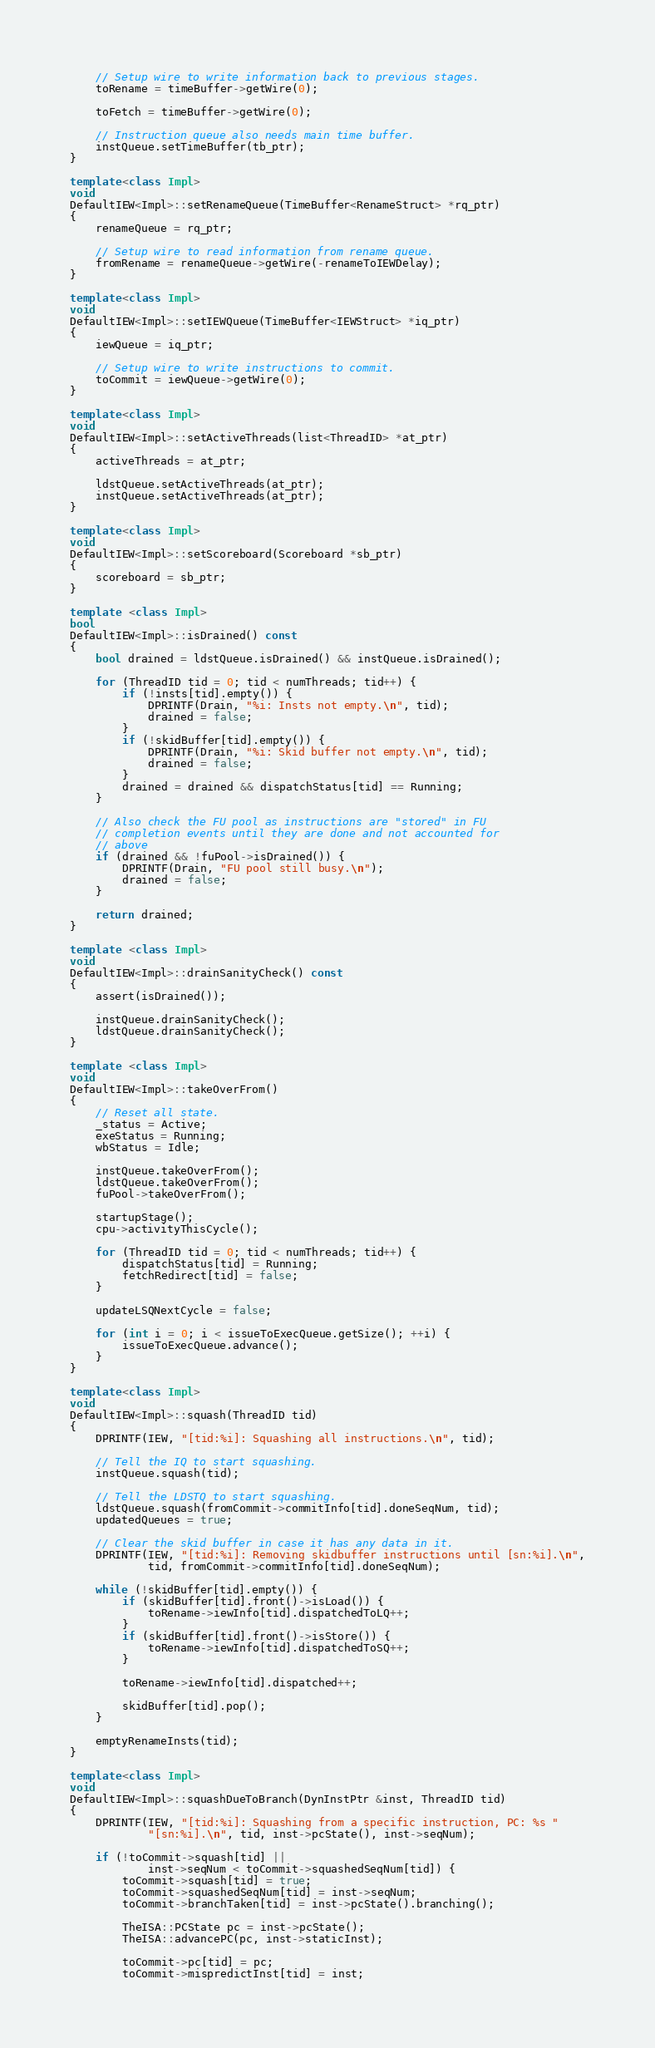Convert code to text. <code><loc_0><loc_0><loc_500><loc_500><_C++_>    // Setup wire to write information back to previous stages.
    toRename = timeBuffer->getWire(0);

    toFetch = timeBuffer->getWire(0);

    // Instruction queue also needs main time buffer.
    instQueue.setTimeBuffer(tb_ptr);
}

template<class Impl>
void
DefaultIEW<Impl>::setRenameQueue(TimeBuffer<RenameStruct> *rq_ptr)
{
    renameQueue = rq_ptr;

    // Setup wire to read information from rename queue.
    fromRename = renameQueue->getWire(-renameToIEWDelay);
}

template<class Impl>
void
DefaultIEW<Impl>::setIEWQueue(TimeBuffer<IEWStruct> *iq_ptr)
{
    iewQueue = iq_ptr;

    // Setup wire to write instructions to commit.
    toCommit = iewQueue->getWire(0);
}

template<class Impl>
void
DefaultIEW<Impl>::setActiveThreads(list<ThreadID> *at_ptr)
{
    activeThreads = at_ptr;

    ldstQueue.setActiveThreads(at_ptr);
    instQueue.setActiveThreads(at_ptr);
}

template<class Impl>
void
DefaultIEW<Impl>::setScoreboard(Scoreboard *sb_ptr)
{
    scoreboard = sb_ptr;
}

template <class Impl>
bool
DefaultIEW<Impl>::isDrained() const
{
    bool drained = ldstQueue.isDrained() && instQueue.isDrained();

    for (ThreadID tid = 0; tid < numThreads; tid++) {
        if (!insts[tid].empty()) {
            DPRINTF(Drain, "%i: Insts not empty.\n", tid);
            drained = false;
        }
        if (!skidBuffer[tid].empty()) {
            DPRINTF(Drain, "%i: Skid buffer not empty.\n", tid);
            drained = false;
        }
        drained = drained && dispatchStatus[tid] == Running;
    }

    // Also check the FU pool as instructions are "stored" in FU
    // completion events until they are done and not accounted for
    // above
    if (drained && !fuPool->isDrained()) {
        DPRINTF(Drain, "FU pool still busy.\n");
        drained = false;
    }

    return drained;
}

template <class Impl>
void
DefaultIEW<Impl>::drainSanityCheck() const
{
    assert(isDrained());

    instQueue.drainSanityCheck();
    ldstQueue.drainSanityCheck();
}

template <class Impl>
void
DefaultIEW<Impl>::takeOverFrom()
{
    // Reset all state.
    _status = Active;
    exeStatus = Running;
    wbStatus = Idle;

    instQueue.takeOverFrom();
    ldstQueue.takeOverFrom();
    fuPool->takeOverFrom();

    startupStage();
    cpu->activityThisCycle();

    for (ThreadID tid = 0; tid < numThreads; tid++) {
        dispatchStatus[tid] = Running;
        fetchRedirect[tid] = false;
    }

    updateLSQNextCycle = false;

    for (int i = 0; i < issueToExecQueue.getSize(); ++i) {
        issueToExecQueue.advance();
    }
}

template<class Impl>
void
DefaultIEW<Impl>::squash(ThreadID tid)
{
    DPRINTF(IEW, "[tid:%i]: Squashing all instructions.\n", tid);

    // Tell the IQ to start squashing.
    instQueue.squash(tid);

    // Tell the LDSTQ to start squashing.
    ldstQueue.squash(fromCommit->commitInfo[tid].doneSeqNum, tid);
    updatedQueues = true;

    // Clear the skid buffer in case it has any data in it.
    DPRINTF(IEW, "[tid:%i]: Removing skidbuffer instructions until [sn:%i].\n",
            tid, fromCommit->commitInfo[tid].doneSeqNum);

    while (!skidBuffer[tid].empty()) {
        if (skidBuffer[tid].front()->isLoad()) {
            toRename->iewInfo[tid].dispatchedToLQ++;
        }
        if (skidBuffer[tid].front()->isStore()) {
            toRename->iewInfo[tid].dispatchedToSQ++;
        }

        toRename->iewInfo[tid].dispatched++;

        skidBuffer[tid].pop();
    }

    emptyRenameInsts(tid);
}

template<class Impl>
void
DefaultIEW<Impl>::squashDueToBranch(DynInstPtr &inst, ThreadID tid)
{
    DPRINTF(IEW, "[tid:%i]: Squashing from a specific instruction, PC: %s "
            "[sn:%i].\n", tid, inst->pcState(), inst->seqNum);

    if (!toCommit->squash[tid] ||
            inst->seqNum < toCommit->squashedSeqNum[tid]) {
        toCommit->squash[tid] = true;
        toCommit->squashedSeqNum[tid] = inst->seqNum;
        toCommit->branchTaken[tid] = inst->pcState().branching();

        TheISA::PCState pc = inst->pcState();
        TheISA::advancePC(pc, inst->staticInst);

        toCommit->pc[tid] = pc;
        toCommit->mispredictInst[tid] = inst;</code> 